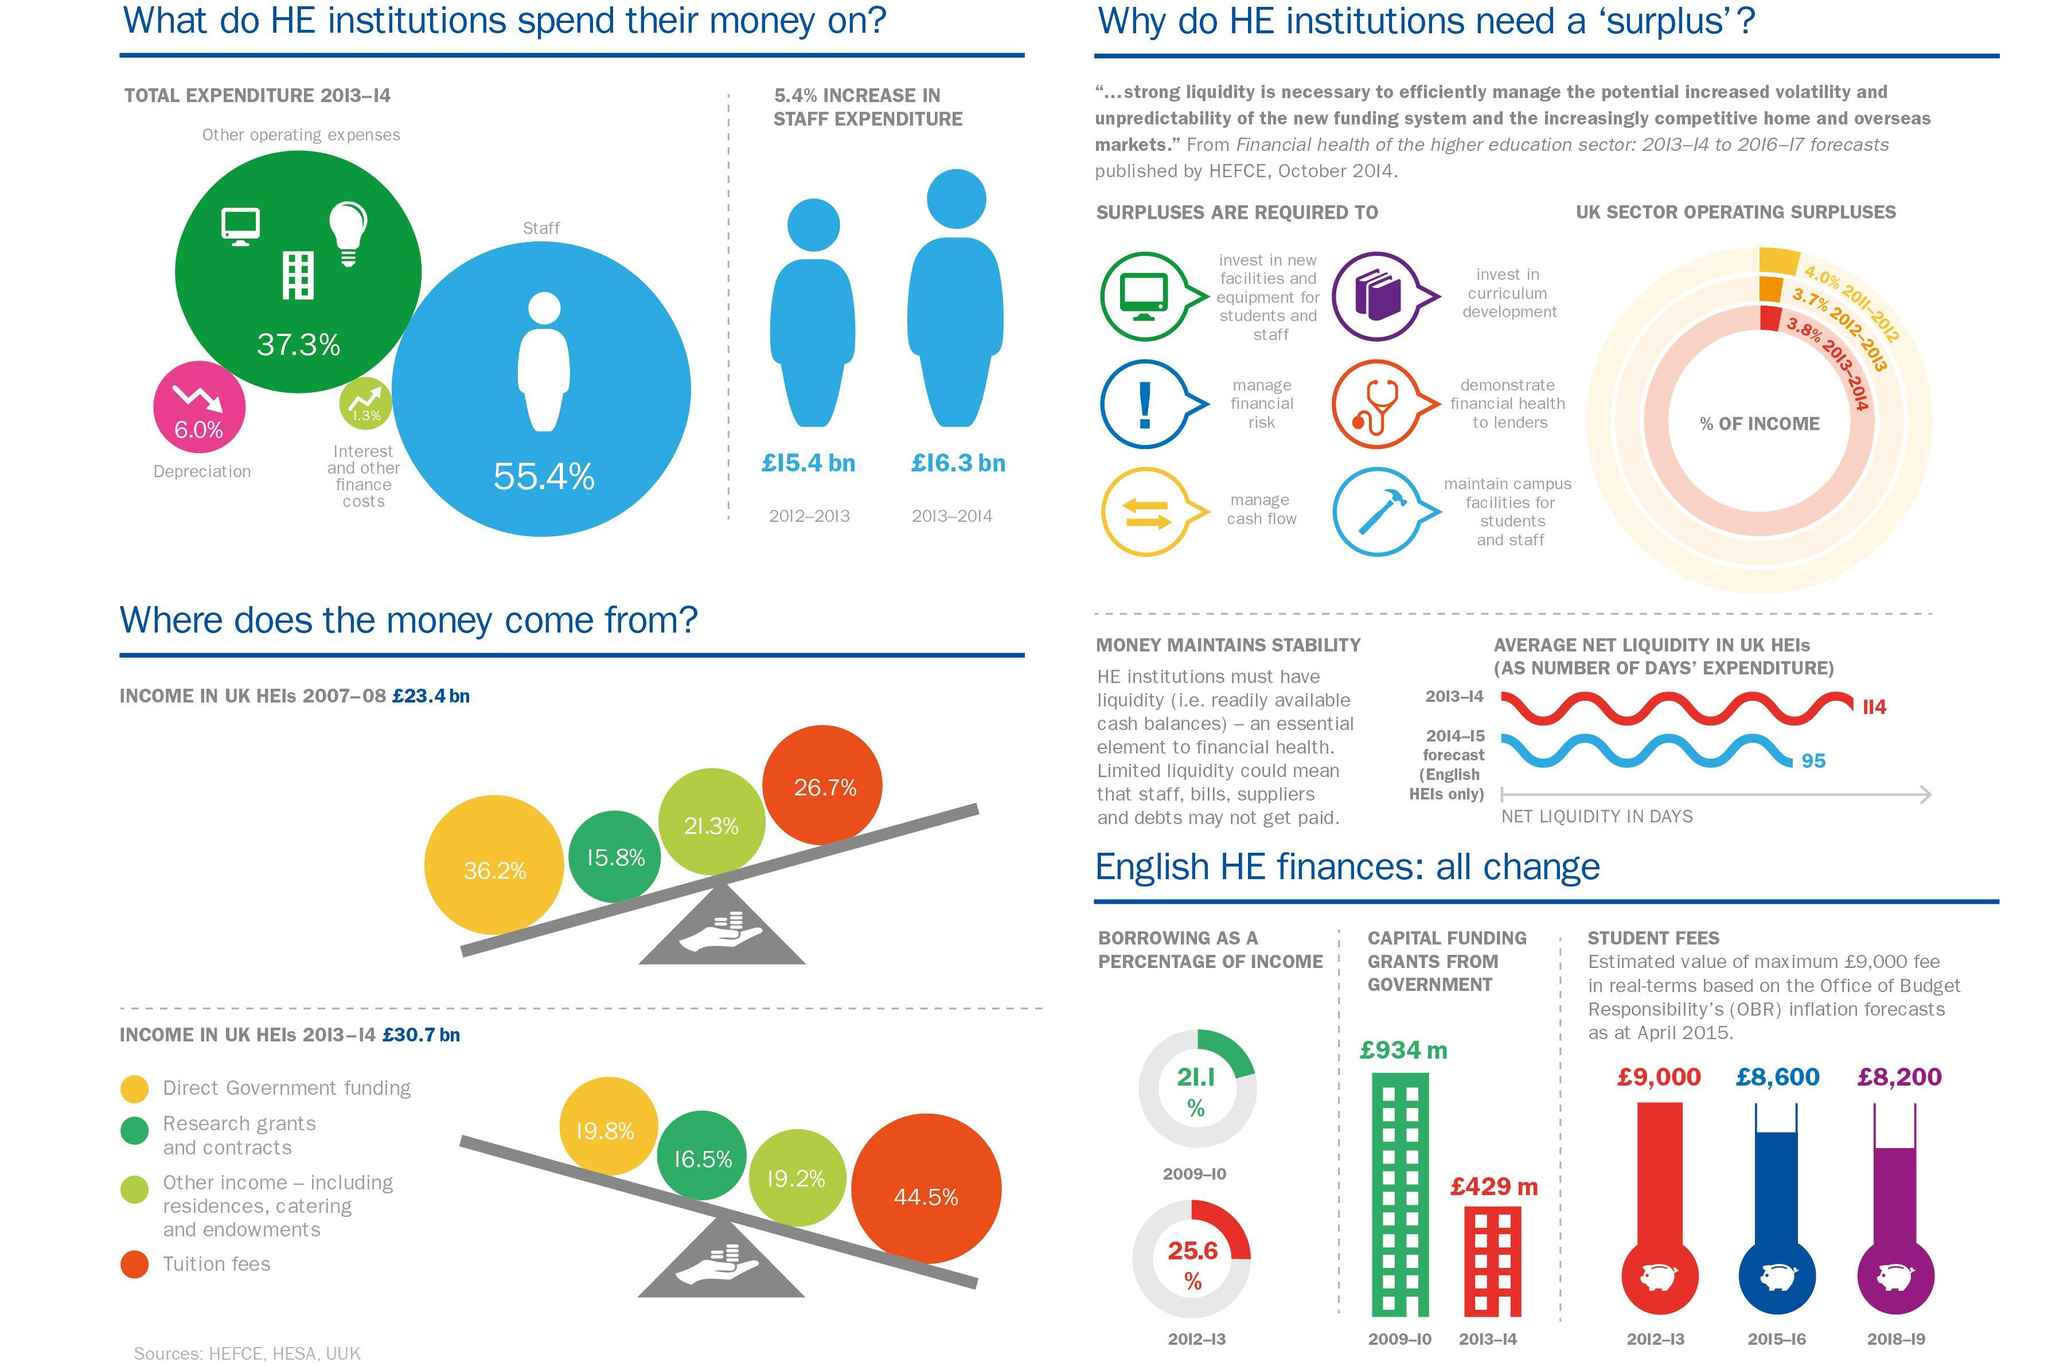What was the largest source of income for the HEIs in UK in 2007-8 ?
Answer the question with a short phrase. Direct government funding What is the image used for surpluses required for the maintenance of campus facilities - books, stethoscope or hammer ? Hammer What percent of the total expenditure was spend on depreciation ? 6.0% What is the colour used to represent income from student fees for 2012-13- red, blue or purple ? Red By what percentage is staff expenses higher than operating expenses in 2013-14? 18.1 What percent of income was from tuition fees in the year 2013-14 ? 44.5% What is the amount of expenditure incurred on staff in the year 2012-13  ? £15.4 bn What was the percentage of borrowing in the year 2012-13  ? 25.6% 